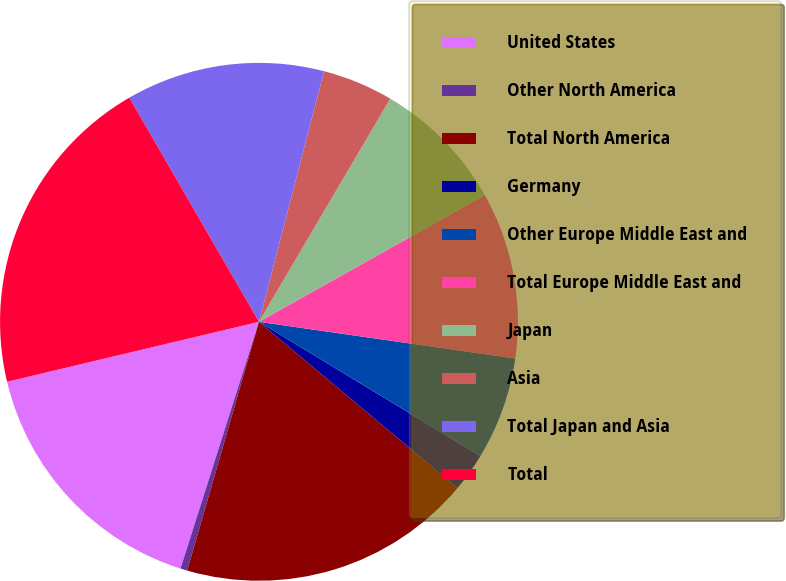<chart> <loc_0><loc_0><loc_500><loc_500><pie_chart><fcel>United States<fcel>Other North America<fcel>Total North America<fcel>Germany<fcel>Other Europe Middle East and<fcel>Total Europe Middle East and<fcel>Japan<fcel>Asia<fcel>Total Japan and Asia<fcel>Total<nl><fcel>16.38%<fcel>0.43%<fcel>18.37%<fcel>2.42%<fcel>6.41%<fcel>10.4%<fcel>8.4%<fcel>4.42%<fcel>12.39%<fcel>20.37%<nl></chart> 